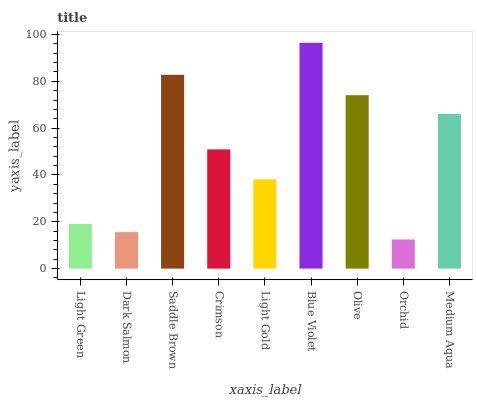Is Orchid the minimum?
Answer yes or no. Yes. Is Blue Violet the maximum?
Answer yes or no. Yes. Is Dark Salmon the minimum?
Answer yes or no. No. Is Dark Salmon the maximum?
Answer yes or no. No. Is Light Green greater than Dark Salmon?
Answer yes or no. Yes. Is Dark Salmon less than Light Green?
Answer yes or no. Yes. Is Dark Salmon greater than Light Green?
Answer yes or no. No. Is Light Green less than Dark Salmon?
Answer yes or no. No. Is Crimson the high median?
Answer yes or no. Yes. Is Crimson the low median?
Answer yes or no. Yes. Is Olive the high median?
Answer yes or no. No. Is Dark Salmon the low median?
Answer yes or no. No. 